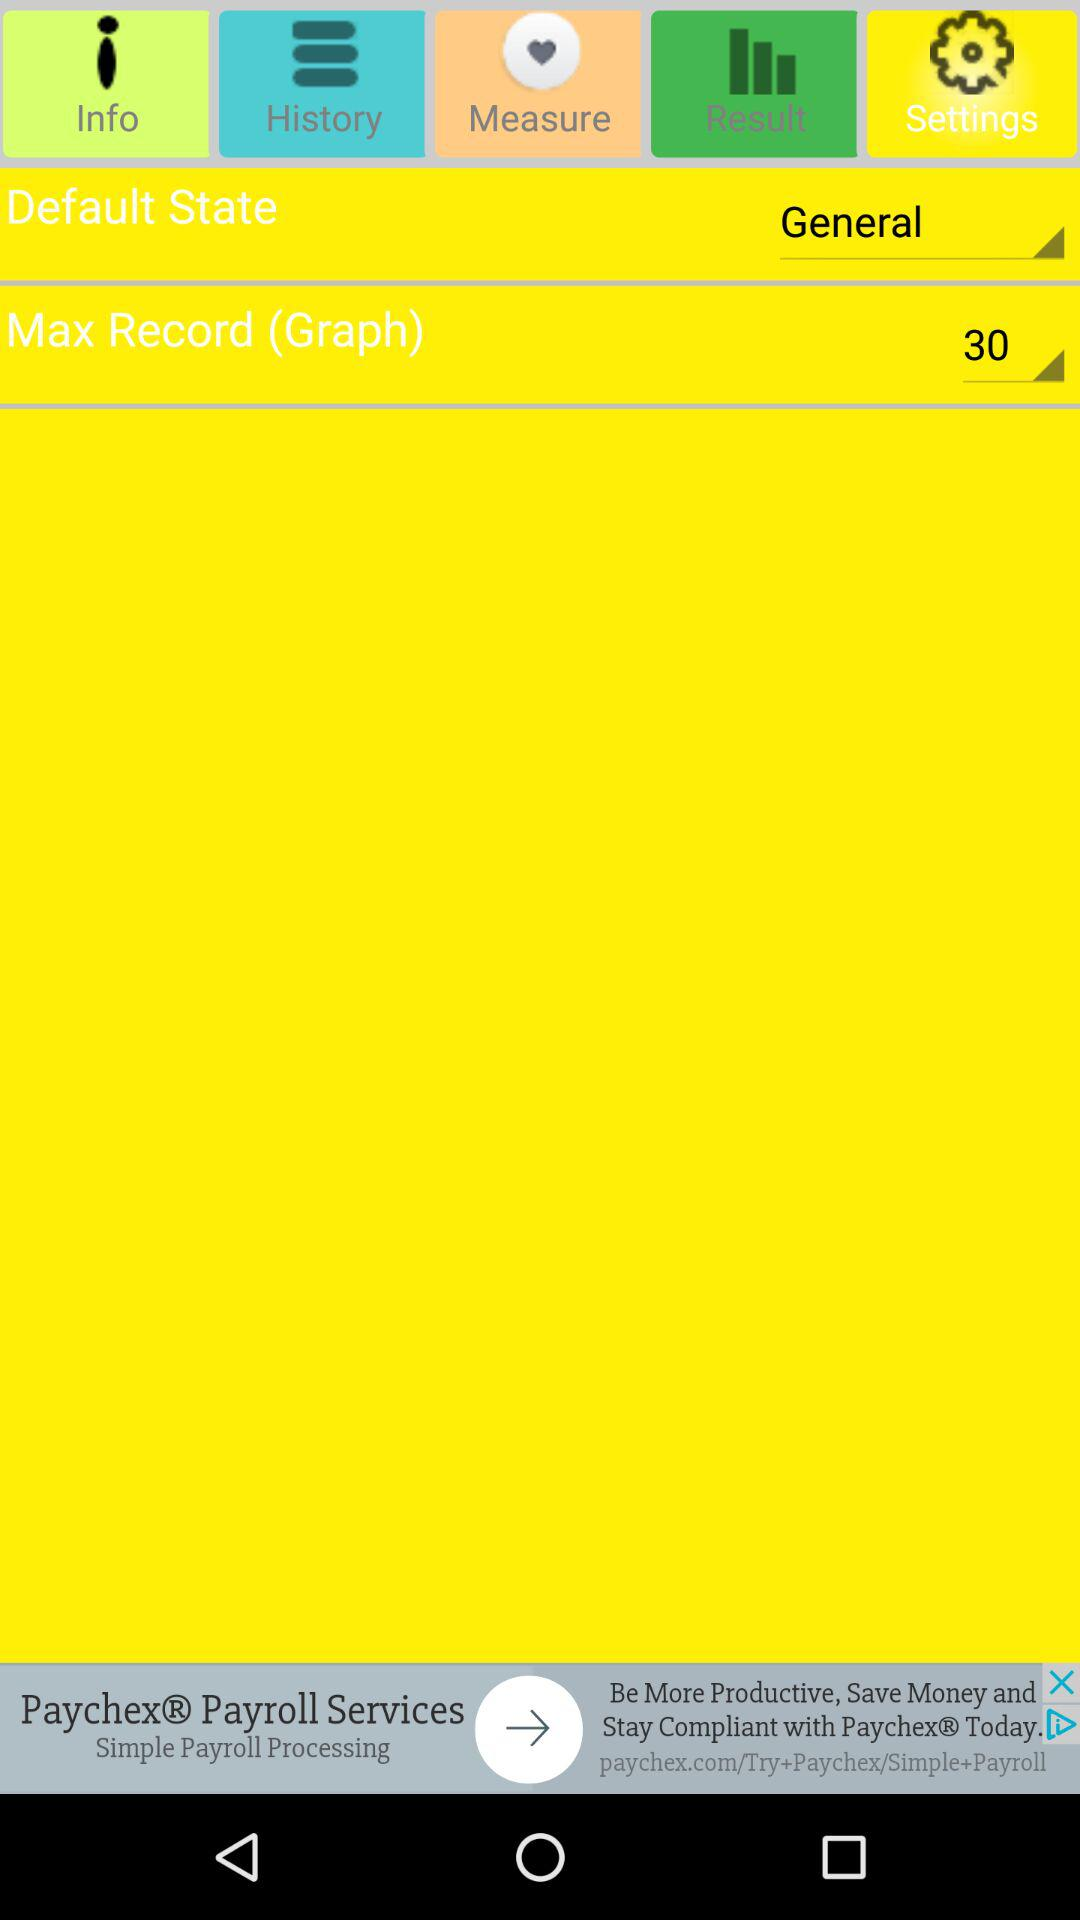Which tab is selected? The selected tab is "Settings". 